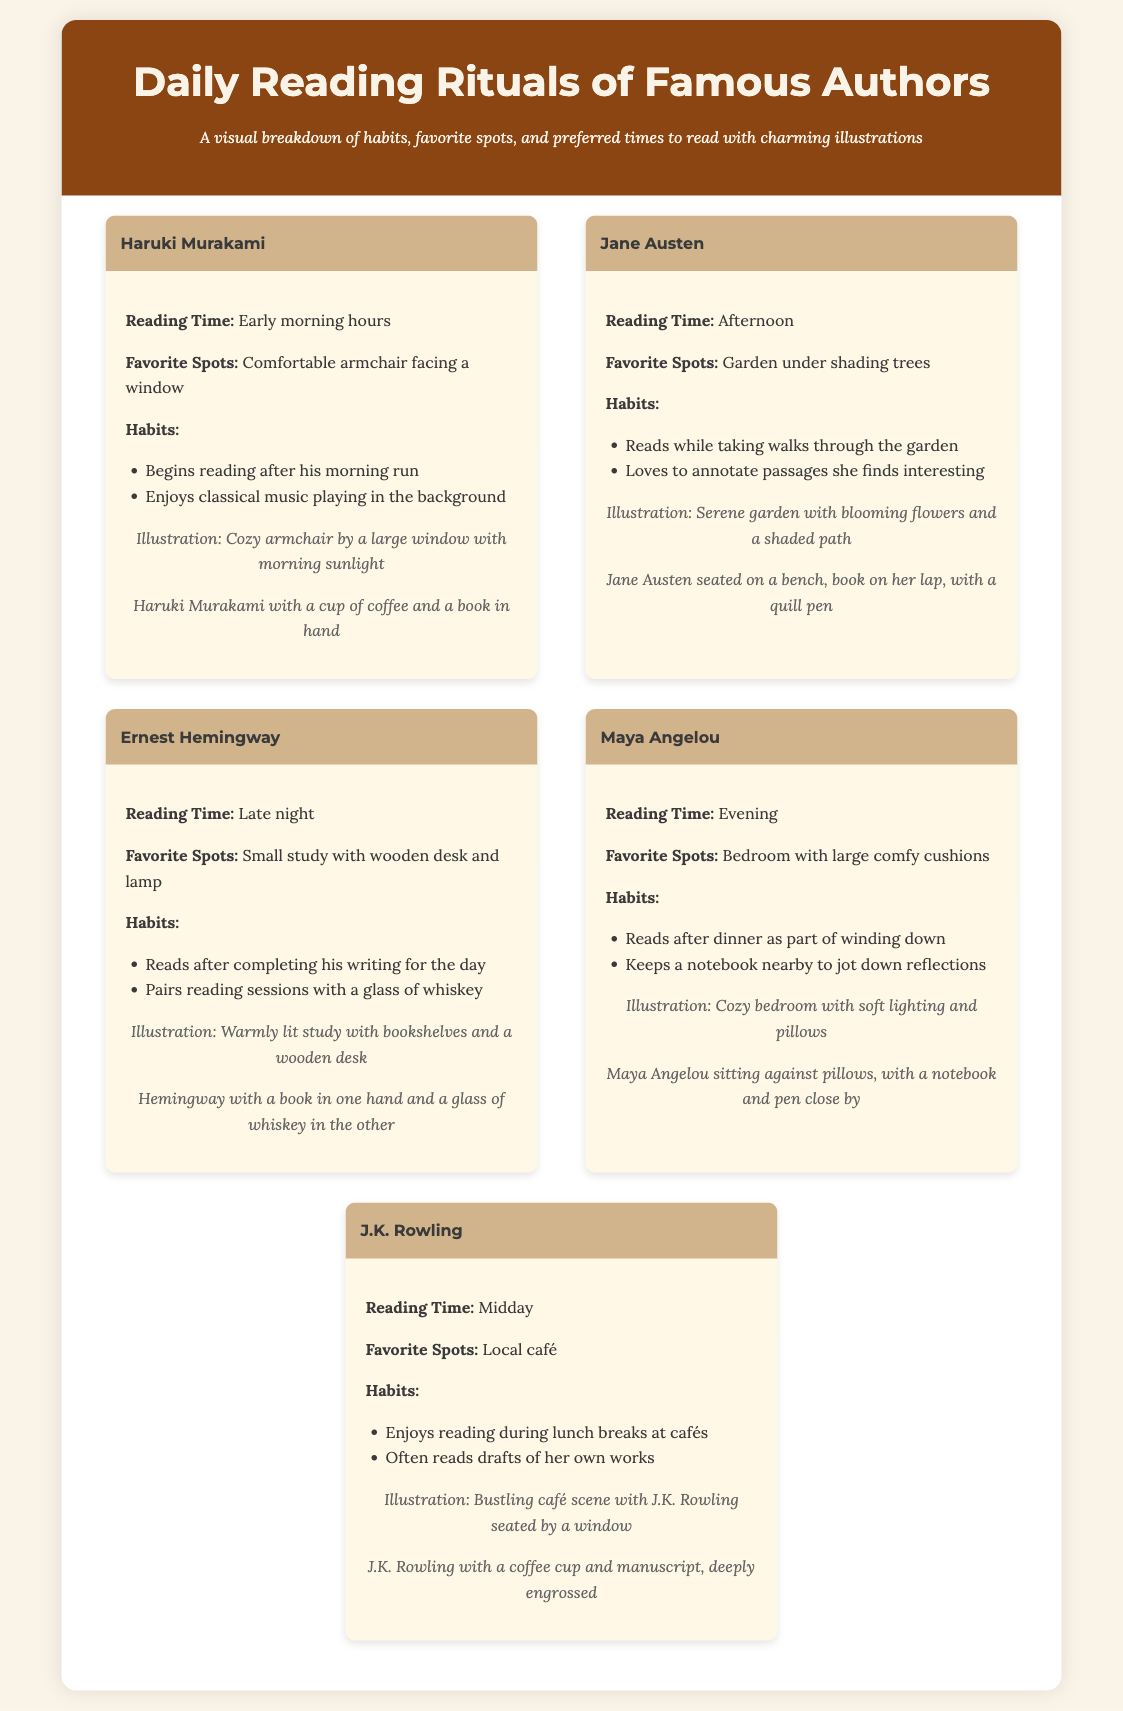What is Haruki Murakami's favorite reading spot? The document states that his favorite spot is a comfortable armchair facing a window.
Answer: Comfortable armchair facing a window What time does Jane Austen prefer to read? According to the document, Jane Austen reads in the afternoon.
Answer: Afternoon What drink does Ernest Hemingway pair with his reading sessions? The document mentions that Hemingway pairs his reading sessions with a glass of whiskey.
Answer: Glass of whiskey What specific habit does Maya Angelou have while reading? The document notes that she keeps a notebook nearby to jot down reflections.
Answer: Keeps a notebook nearby Which author reads during lunch breaks at cafés? The document indicates that J.K. Rowling enjoys reading during lunch breaks at cafés.
Answer: J.K. Rowling Who is illustrated seated against pillows with a notebook? The illustration depicts Maya Angelou sitting against pillows with a notebook and pen close by.
Answer: Maya Angelou How does Haruki Murakami prepare for his reading time? It is stated that he begins reading after his morning run.
Answer: After his morning run What is the common theme of the reading spots for these authors? The document reveals that all authors have personal, cozy, and serene places for reading.
Answer: Personal, cozy, and serene places What is the primary reading time for Maya Angelou? Maya Angelou's primary reading time is in the evening.
Answer: Evening 